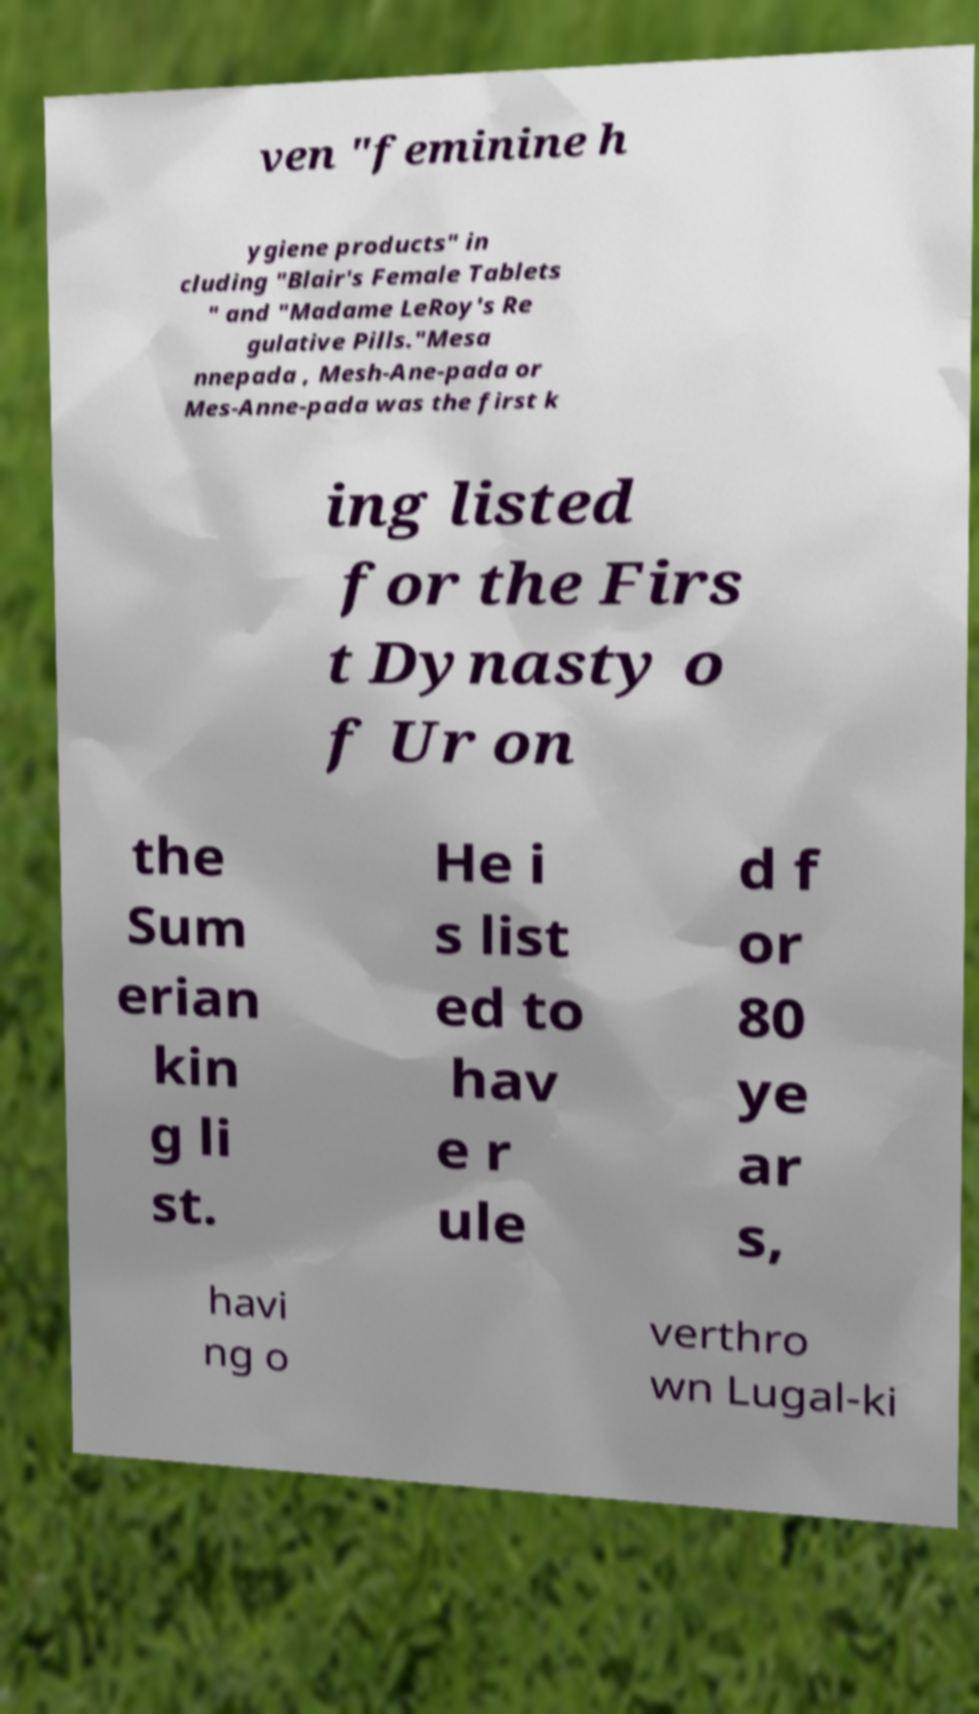Can you accurately transcribe the text from the provided image for me? ven "feminine h ygiene products" in cluding "Blair's Female Tablets " and "Madame LeRoy's Re gulative Pills."Mesa nnepada , Mesh-Ane-pada or Mes-Anne-pada was the first k ing listed for the Firs t Dynasty o f Ur on the Sum erian kin g li st. He i s list ed to hav e r ule d f or 80 ye ar s, havi ng o verthro wn Lugal-ki 